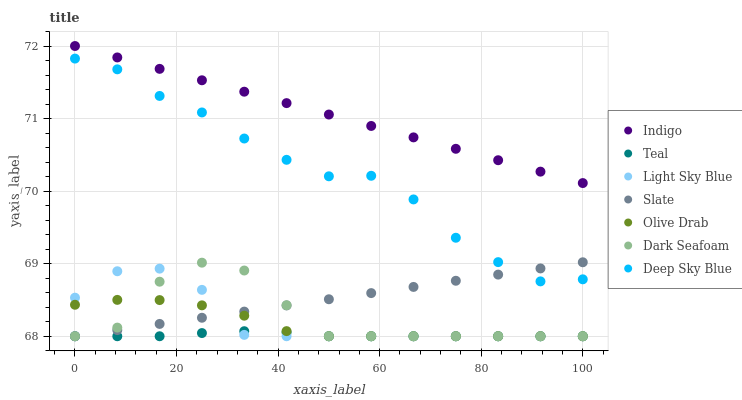Does Teal have the minimum area under the curve?
Answer yes or no. Yes. Does Indigo have the maximum area under the curve?
Answer yes or no. Yes. Does Deep Sky Blue have the minimum area under the curve?
Answer yes or no. No. Does Deep Sky Blue have the maximum area under the curve?
Answer yes or no. No. Is Indigo the smoothest?
Answer yes or no. Yes. Is Dark Seafoam the roughest?
Answer yes or no. Yes. Is Deep Sky Blue the smoothest?
Answer yes or no. No. Is Deep Sky Blue the roughest?
Answer yes or no. No. Does Slate have the lowest value?
Answer yes or no. Yes. Does Deep Sky Blue have the lowest value?
Answer yes or no. No. Does Indigo have the highest value?
Answer yes or no. Yes. Does Deep Sky Blue have the highest value?
Answer yes or no. No. Is Light Sky Blue less than Indigo?
Answer yes or no. Yes. Is Indigo greater than Light Sky Blue?
Answer yes or no. Yes. Does Olive Drab intersect Dark Seafoam?
Answer yes or no. Yes. Is Olive Drab less than Dark Seafoam?
Answer yes or no. No. Is Olive Drab greater than Dark Seafoam?
Answer yes or no. No. Does Light Sky Blue intersect Indigo?
Answer yes or no. No. 